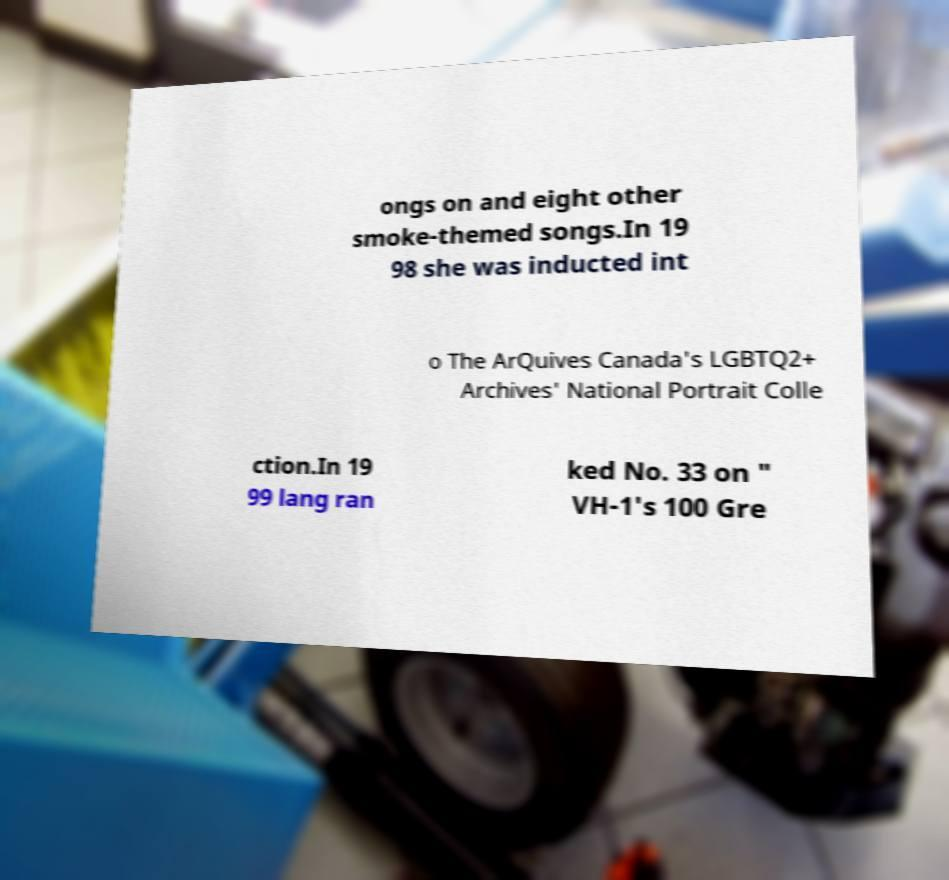Can you accurately transcribe the text from the provided image for me? ongs on and eight other smoke-themed songs.In 19 98 she was inducted int o The ArQuives Canada's LGBTQ2+ Archives' National Portrait Colle ction.In 19 99 lang ran ked No. 33 on " VH-1's 100 Gre 